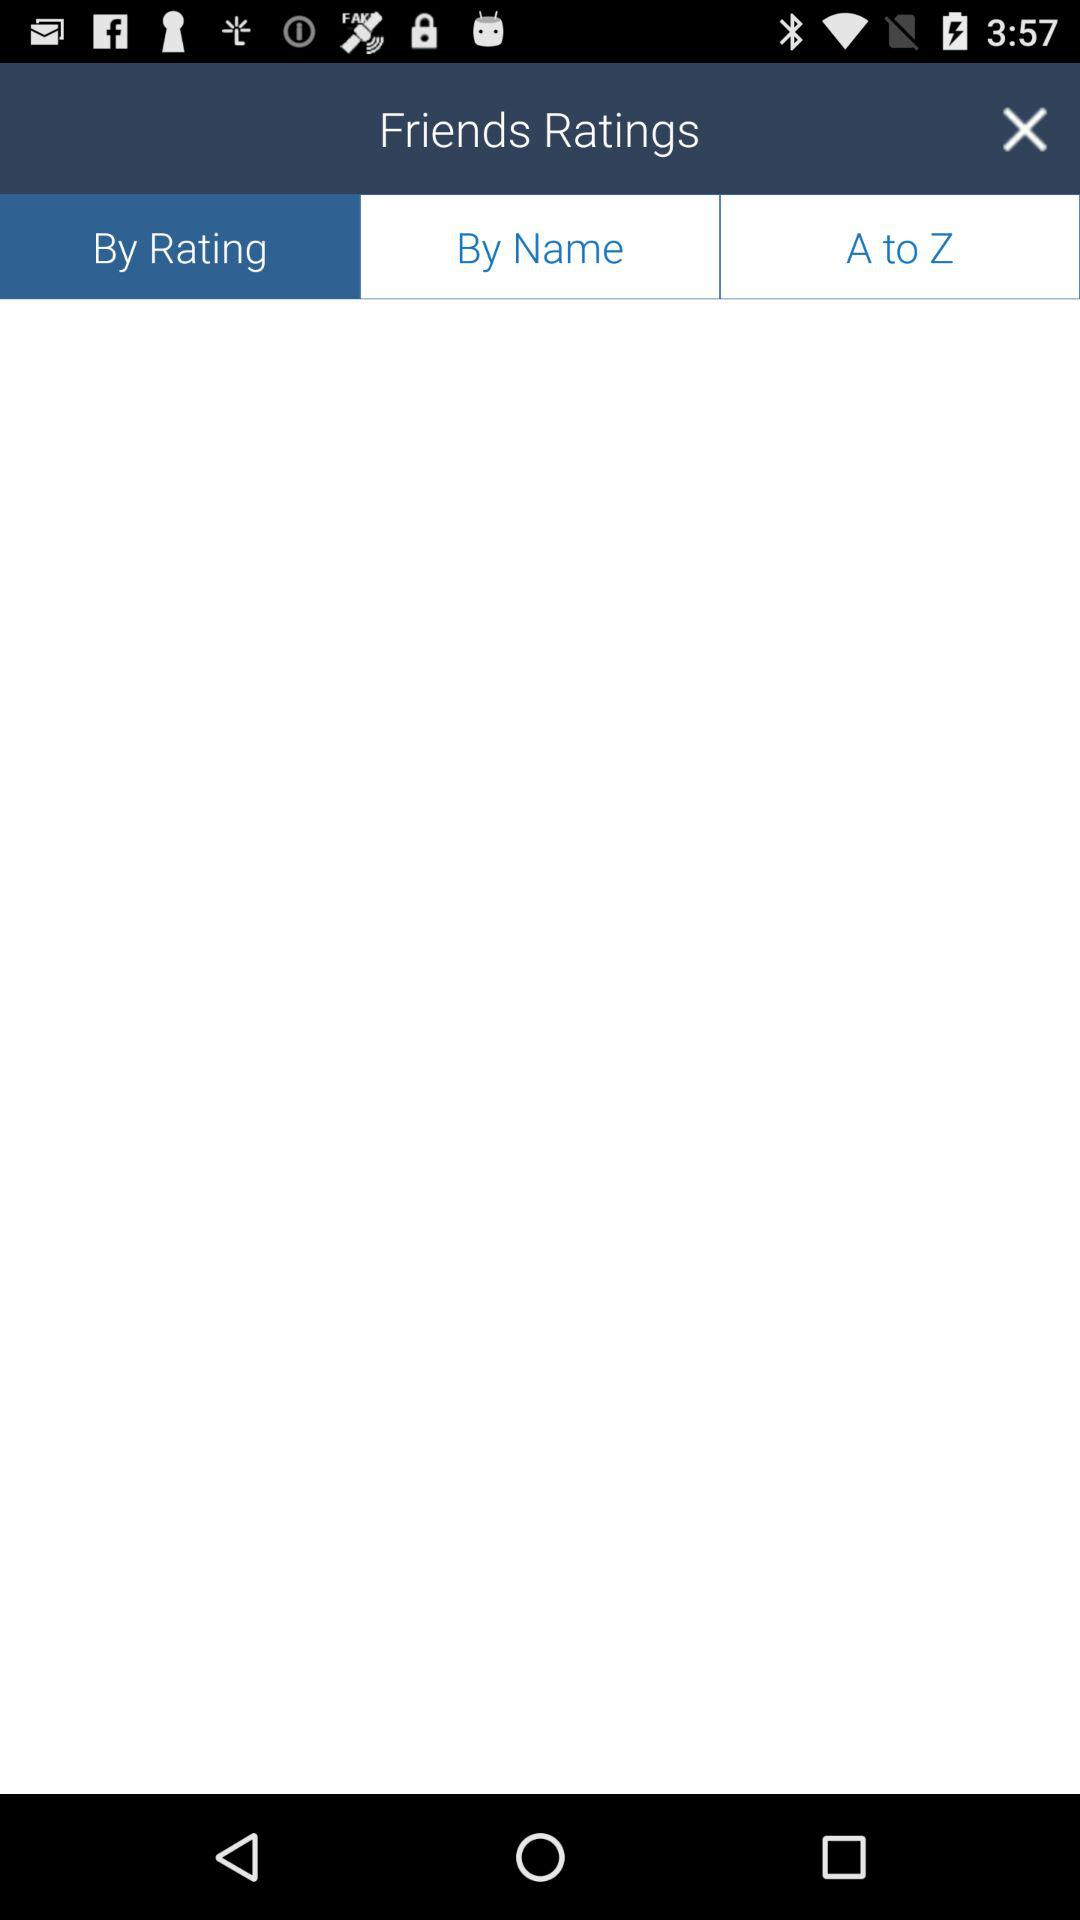Which option is selected? The selected option is "By Rating". 